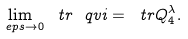<formula> <loc_0><loc_0><loc_500><loc_500>\lim _ { \ e p s \to 0 } \ t r { \ q v i } = \ t r Q ^ { \lambda } _ { 4 } .</formula> 